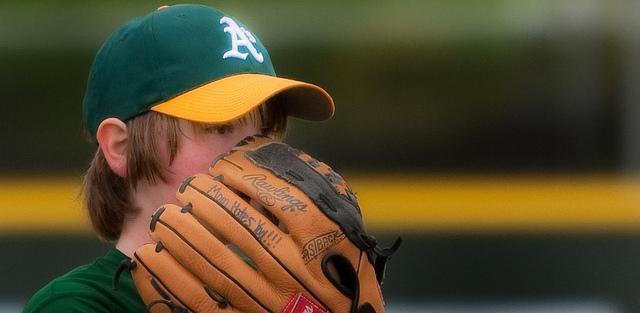Verify the accuracy of this image caption: "The baseball glove is in front of the person.".
Answer yes or no. Yes. 